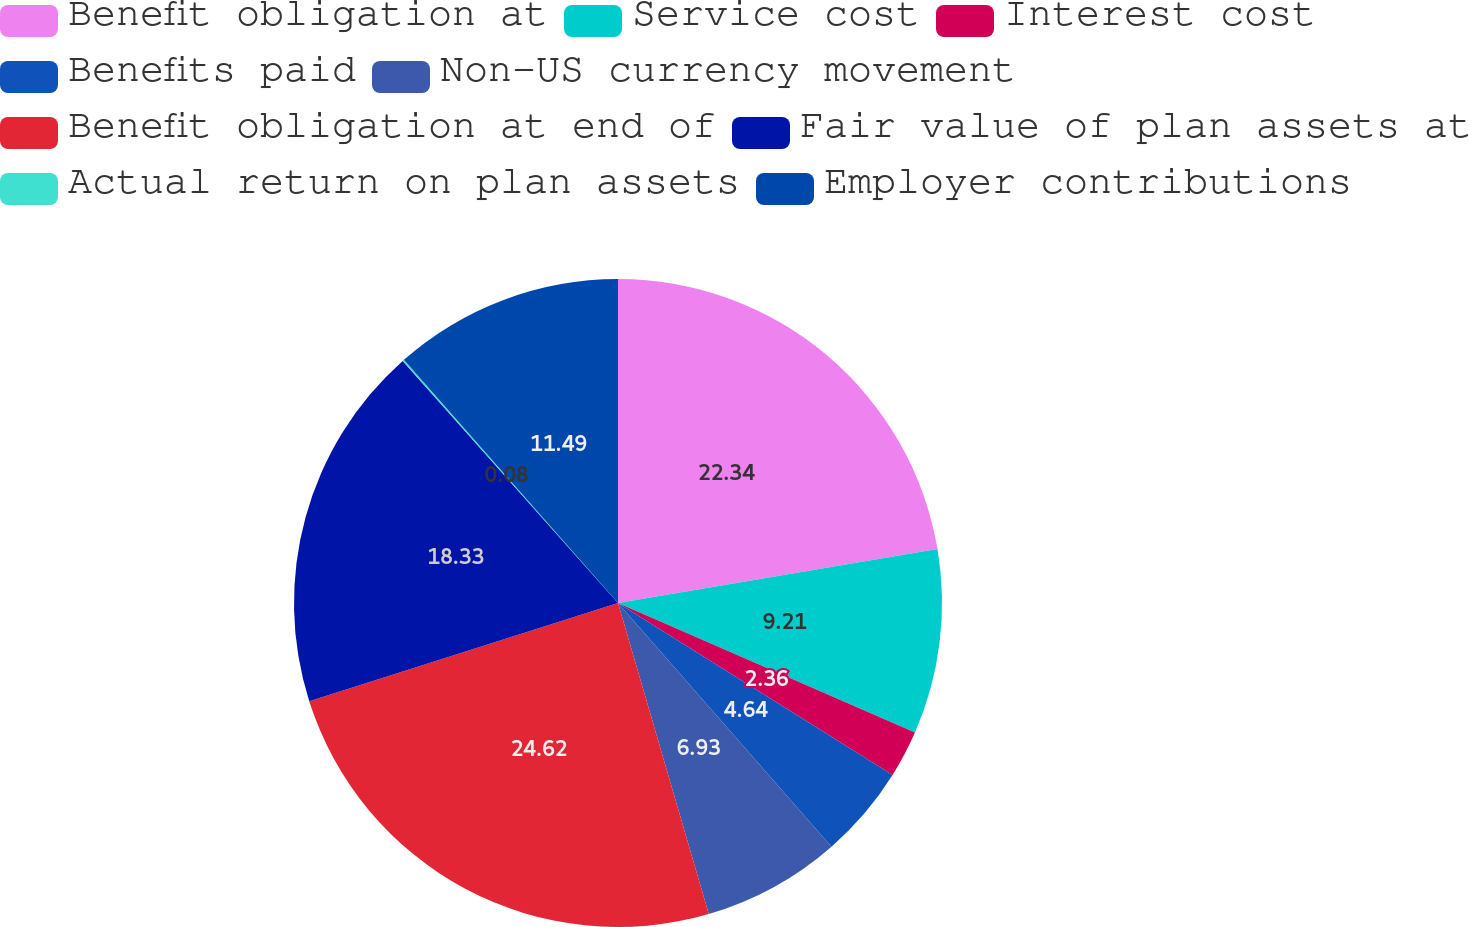Convert chart. <chart><loc_0><loc_0><loc_500><loc_500><pie_chart><fcel>Benefit obligation at<fcel>Service cost<fcel>Interest cost<fcel>Benefits paid<fcel>Non-US currency movement<fcel>Benefit obligation at end of<fcel>Fair value of plan assets at<fcel>Actual return on plan assets<fcel>Employer contributions<nl><fcel>22.34%<fcel>9.21%<fcel>2.36%<fcel>4.64%<fcel>6.93%<fcel>24.62%<fcel>18.33%<fcel>0.08%<fcel>11.49%<nl></chart> 